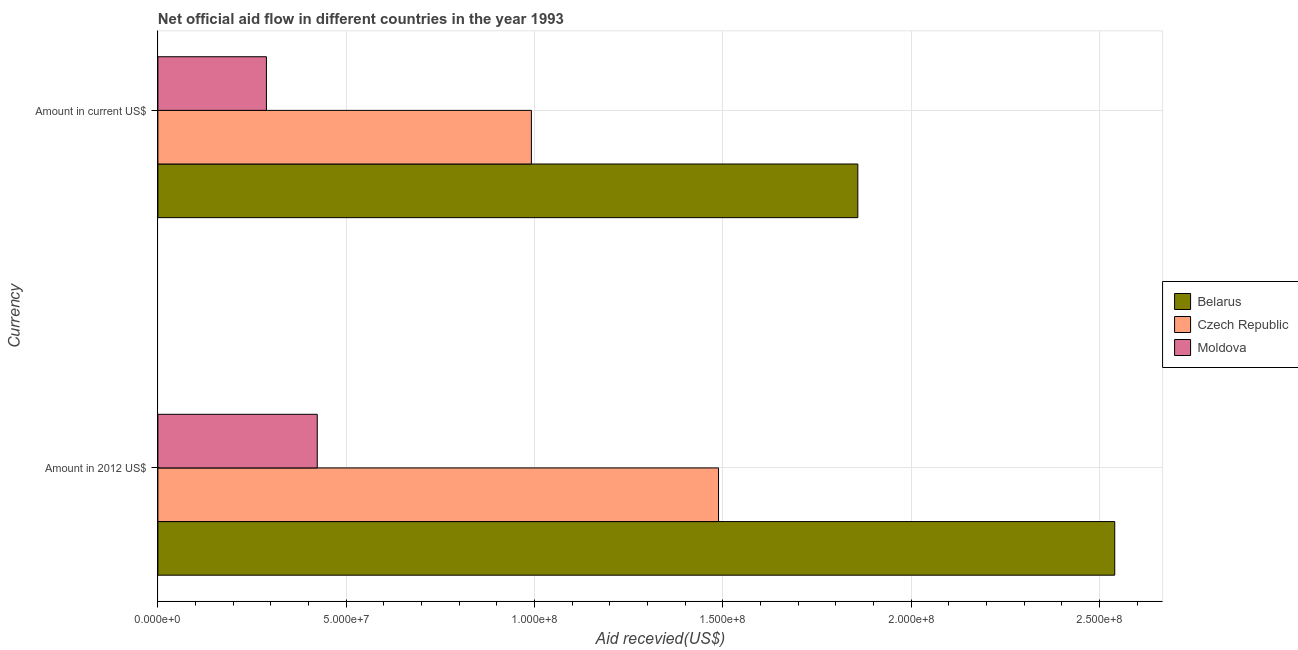How many groups of bars are there?
Your answer should be compact. 2. How many bars are there on the 2nd tick from the top?
Provide a short and direct response. 3. What is the label of the 2nd group of bars from the top?
Give a very brief answer. Amount in 2012 US$. What is the amount of aid received(expressed in 2012 us$) in Belarus?
Make the answer very short. 2.54e+08. Across all countries, what is the maximum amount of aid received(expressed in us$)?
Ensure brevity in your answer.  1.86e+08. Across all countries, what is the minimum amount of aid received(expressed in 2012 us$)?
Your answer should be very brief. 4.23e+07. In which country was the amount of aid received(expressed in us$) maximum?
Your answer should be compact. Belarus. In which country was the amount of aid received(expressed in 2012 us$) minimum?
Provide a short and direct response. Moldova. What is the total amount of aid received(expressed in 2012 us$) in the graph?
Your answer should be compact. 4.45e+08. What is the difference between the amount of aid received(expressed in 2012 us$) in Belarus and that in Czech Republic?
Give a very brief answer. 1.05e+08. What is the difference between the amount of aid received(expressed in 2012 us$) in Czech Republic and the amount of aid received(expressed in us$) in Moldova?
Give a very brief answer. 1.20e+08. What is the average amount of aid received(expressed in us$) per country?
Make the answer very short. 1.05e+08. What is the difference between the amount of aid received(expressed in 2012 us$) and amount of aid received(expressed in us$) in Czech Republic?
Give a very brief answer. 4.97e+07. In how many countries, is the amount of aid received(expressed in 2012 us$) greater than 60000000 US$?
Provide a succinct answer. 2. What is the ratio of the amount of aid received(expressed in 2012 us$) in Czech Republic to that in Moldova?
Provide a short and direct response. 3.52. In how many countries, is the amount of aid received(expressed in 2012 us$) greater than the average amount of aid received(expressed in 2012 us$) taken over all countries?
Your answer should be compact. 2. What does the 1st bar from the top in Amount in current US$ represents?
Your response must be concise. Moldova. What does the 3rd bar from the bottom in Amount in 2012 US$ represents?
Your answer should be very brief. Moldova. How many bars are there?
Keep it short and to the point. 6. What is the difference between two consecutive major ticks on the X-axis?
Offer a terse response. 5.00e+07. Does the graph contain any zero values?
Make the answer very short. No. Does the graph contain grids?
Ensure brevity in your answer.  Yes. How many legend labels are there?
Keep it short and to the point. 3. How are the legend labels stacked?
Your answer should be very brief. Vertical. What is the title of the graph?
Give a very brief answer. Net official aid flow in different countries in the year 1993. Does "Egypt, Arab Rep." appear as one of the legend labels in the graph?
Your response must be concise. No. What is the label or title of the X-axis?
Provide a succinct answer. Aid recevied(US$). What is the label or title of the Y-axis?
Your answer should be very brief. Currency. What is the Aid recevied(US$) of Belarus in Amount in 2012 US$?
Your answer should be compact. 2.54e+08. What is the Aid recevied(US$) in Czech Republic in Amount in 2012 US$?
Your response must be concise. 1.49e+08. What is the Aid recevied(US$) in Moldova in Amount in 2012 US$?
Offer a very short reply. 4.23e+07. What is the Aid recevied(US$) of Belarus in Amount in current US$?
Your response must be concise. 1.86e+08. What is the Aid recevied(US$) in Czech Republic in Amount in current US$?
Offer a terse response. 9.92e+07. What is the Aid recevied(US$) in Moldova in Amount in current US$?
Keep it short and to the point. 2.88e+07. Across all Currency, what is the maximum Aid recevied(US$) of Belarus?
Give a very brief answer. 2.54e+08. Across all Currency, what is the maximum Aid recevied(US$) in Czech Republic?
Offer a terse response. 1.49e+08. Across all Currency, what is the maximum Aid recevied(US$) of Moldova?
Ensure brevity in your answer.  4.23e+07. Across all Currency, what is the minimum Aid recevied(US$) in Belarus?
Offer a terse response. 1.86e+08. Across all Currency, what is the minimum Aid recevied(US$) of Czech Republic?
Make the answer very short. 9.92e+07. Across all Currency, what is the minimum Aid recevied(US$) of Moldova?
Your answer should be compact. 2.88e+07. What is the total Aid recevied(US$) of Belarus in the graph?
Your answer should be compact. 4.40e+08. What is the total Aid recevied(US$) of Czech Republic in the graph?
Give a very brief answer. 2.48e+08. What is the total Aid recevied(US$) in Moldova in the graph?
Provide a succinct answer. 7.11e+07. What is the difference between the Aid recevied(US$) of Belarus in Amount in 2012 US$ and that in Amount in current US$?
Make the answer very short. 6.82e+07. What is the difference between the Aid recevied(US$) in Czech Republic in Amount in 2012 US$ and that in Amount in current US$?
Give a very brief answer. 4.97e+07. What is the difference between the Aid recevied(US$) of Moldova in Amount in 2012 US$ and that in Amount in current US$?
Your answer should be very brief. 1.35e+07. What is the difference between the Aid recevied(US$) in Belarus in Amount in 2012 US$ and the Aid recevied(US$) in Czech Republic in Amount in current US$?
Give a very brief answer. 1.55e+08. What is the difference between the Aid recevied(US$) in Belarus in Amount in 2012 US$ and the Aid recevied(US$) in Moldova in Amount in current US$?
Offer a terse response. 2.25e+08. What is the difference between the Aid recevied(US$) of Czech Republic in Amount in 2012 US$ and the Aid recevied(US$) of Moldova in Amount in current US$?
Ensure brevity in your answer.  1.20e+08. What is the average Aid recevied(US$) of Belarus per Currency?
Keep it short and to the point. 2.20e+08. What is the average Aid recevied(US$) in Czech Republic per Currency?
Ensure brevity in your answer.  1.24e+08. What is the average Aid recevied(US$) of Moldova per Currency?
Provide a short and direct response. 3.56e+07. What is the difference between the Aid recevied(US$) in Belarus and Aid recevied(US$) in Czech Republic in Amount in 2012 US$?
Offer a very short reply. 1.05e+08. What is the difference between the Aid recevied(US$) in Belarus and Aid recevied(US$) in Moldova in Amount in 2012 US$?
Your answer should be compact. 2.12e+08. What is the difference between the Aid recevied(US$) in Czech Republic and Aid recevied(US$) in Moldova in Amount in 2012 US$?
Your answer should be very brief. 1.07e+08. What is the difference between the Aid recevied(US$) of Belarus and Aid recevied(US$) of Czech Republic in Amount in current US$?
Provide a short and direct response. 8.67e+07. What is the difference between the Aid recevied(US$) in Belarus and Aid recevied(US$) in Moldova in Amount in current US$?
Offer a very short reply. 1.57e+08. What is the difference between the Aid recevied(US$) in Czech Republic and Aid recevied(US$) in Moldova in Amount in current US$?
Your answer should be compact. 7.03e+07. What is the ratio of the Aid recevied(US$) in Belarus in Amount in 2012 US$ to that in Amount in current US$?
Keep it short and to the point. 1.37. What is the ratio of the Aid recevied(US$) of Czech Republic in Amount in 2012 US$ to that in Amount in current US$?
Your answer should be very brief. 1.5. What is the ratio of the Aid recevied(US$) in Moldova in Amount in 2012 US$ to that in Amount in current US$?
Make the answer very short. 1.47. What is the difference between the highest and the second highest Aid recevied(US$) of Belarus?
Offer a terse response. 6.82e+07. What is the difference between the highest and the second highest Aid recevied(US$) of Czech Republic?
Provide a short and direct response. 4.97e+07. What is the difference between the highest and the second highest Aid recevied(US$) in Moldova?
Provide a succinct answer. 1.35e+07. What is the difference between the highest and the lowest Aid recevied(US$) in Belarus?
Make the answer very short. 6.82e+07. What is the difference between the highest and the lowest Aid recevied(US$) in Czech Republic?
Provide a short and direct response. 4.97e+07. What is the difference between the highest and the lowest Aid recevied(US$) in Moldova?
Your answer should be compact. 1.35e+07. 